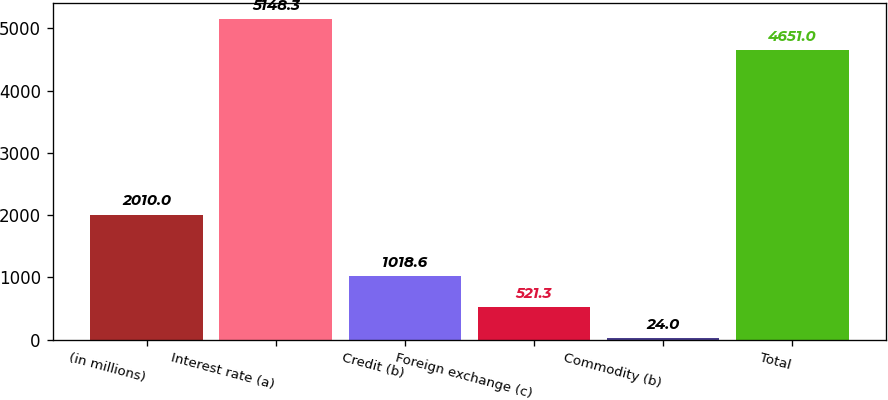Convert chart. <chart><loc_0><loc_0><loc_500><loc_500><bar_chart><fcel>(in millions)<fcel>Interest rate (a)<fcel>Credit (b)<fcel>Foreign exchange (c)<fcel>Commodity (b)<fcel>Total<nl><fcel>2010<fcel>5148.3<fcel>1018.6<fcel>521.3<fcel>24<fcel>4651<nl></chart> 